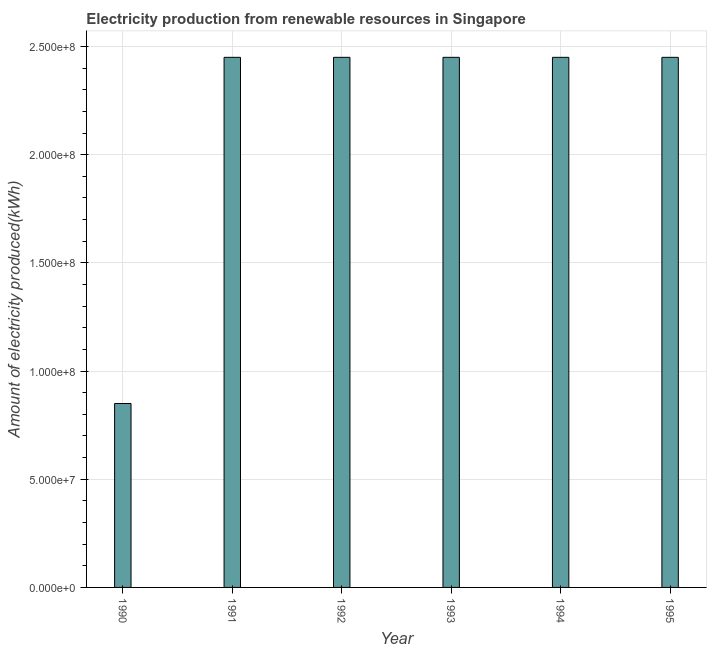What is the title of the graph?
Provide a short and direct response. Electricity production from renewable resources in Singapore. What is the label or title of the Y-axis?
Your response must be concise. Amount of electricity produced(kWh). What is the amount of electricity produced in 1992?
Ensure brevity in your answer.  2.45e+08. Across all years, what is the maximum amount of electricity produced?
Give a very brief answer. 2.45e+08. Across all years, what is the minimum amount of electricity produced?
Your response must be concise. 8.50e+07. In which year was the amount of electricity produced minimum?
Offer a very short reply. 1990. What is the sum of the amount of electricity produced?
Offer a terse response. 1.31e+09. What is the difference between the amount of electricity produced in 1990 and 1992?
Ensure brevity in your answer.  -1.60e+08. What is the average amount of electricity produced per year?
Your answer should be compact. 2.18e+08. What is the median amount of electricity produced?
Offer a very short reply. 2.45e+08. In how many years, is the amount of electricity produced greater than 170000000 kWh?
Your response must be concise. 5. Do a majority of the years between 1990 and 1995 (inclusive) have amount of electricity produced greater than 130000000 kWh?
Give a very brief answer. Yes. Is the amount of electricity produced in 1991 less than that in 1994?
Your answer should be compact. No. Is the difference between the amount of electricity produced in 1993 and 1994 greater than the difference between any two years?
Make the answer very short. No. Is the sum of the amount of electricity produced in 1993 and 1995 greater than the maximum amount of electricity produced across all years?
Your response must be concise. Yes. What is the difference between the highest and the lowest amount of electricity produced?
Ensure brevity in your answer.  1.60e+08. In how many years, is the amount of electricity produced greater than the average amount of electricity produced taken over all years?
Your response must be concise. 5. How many bars are there?
Make the answer very short. 6. Are all the bars in the graph horizontal?
Give a very brief answer. No. How many years are there in the graph?
Provide a short and direct response. 6. What is the difference between two consecutive major ticks on the Y-axis?
Offer a very short reply. 5.00e+07. Are the values on the major ticks of Y-axis written in scientific E-notation?
Provide a short and direct response. Yes. What is the Amount of electricity produced(kWh) of 1990?
Your answer should be compact. 8.50e+07. What is the Amount of electricity produced(kWh) in 1991?
Your answer should be very brief. 2.45e+08. What is the Amount of electricity produced(kWh) in 1992?
Give a very brief answer. 2.45e+08. What is the Amount of electricity produced(kWh) in 1993?
Provide a succinct answer. 2.45e+08. What is the Amount of electricity produced(kWh) in 1994?
Ensure brevity in your answer.  2.45e+08. What is the Amount of electricity produced(kWh) in 1995?
Offer a terse response. 2.45e+08. What is the difference between the Amount of electricity produced(kWh) in 1990 and 1991?
Keep it short and to the point. -1.60e+08. What is the difference between the Amount of electricity produced(kWh) in 1990 and 1992?
Provide a succinct answer. -1.60e+08. What is the difference between the Amount of electricity produced(kWh) in 1990 and 1993?
Provide a succinct answer. -1.60e+08. What is the difference between the Amount of electricity produced(kWh) in 1990 and 1994?
Your answer should be very brief. -1.60e+08. What is the difference between the Amount of electricity produced(kWh) in 1990 and 1995?
Provide a short and direct response. -1.60e+08. What is the difference between the Amount of electricity produced(kWh) in 1992 and 1994?
Provide a succinct answer. 0. What is the difference between the Amount of electricity produced(kWh) in 1992 and 1995?
Give a very brief answer. 0. What is the difference between the Amount of electricity produced(kWh) in 1993 and 1995?
Provide a short and direct response. 0. What is the ratio of the Amount of electricity produced(kWh) in 1990 to that in 1991?
Give a very brief answer. 0.35. What is the ratio of the Amount of electricity produced(kWh) in 1990 to that in 1992?
Your response must be concise. 0.35. What is the ratio of the Amount of electricity produced(kWh) in 1990 to that in 1993?
Provide a succinct answer. 0.35. What is the ratio of the Amount of electricity produced(kWh) in 1990 to that in 1994?
Your response must be concise. 0.35. What is the ratio of the Amount of electricity produced(kWh) in 1990 to that in 1995?
Your answer should be compact. 0.35. What is the ratio of the Amount of electricity produced(kWh) in 1991 to that in 1992?
Offer a terse response. 1. What is the ratio of the Amount of electricity produced(kWh) in 1992 to that in 1995?
Ensure brevity in your answer.  1. What is the ratio of the Amount of electricity produced(kWh) in 1993 to that in 1994?
Ensure brevity in your answer.  1. What is the ratio of the Amount of electricity produced(kWh) in 1994 to that in 1995?
Offer a very short reply. 1. 